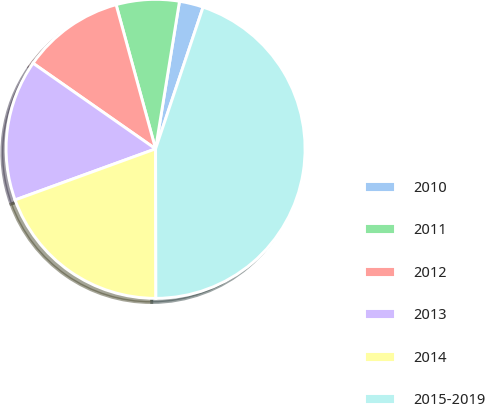Convert chart. <chart><loc_0><loc_0><loc_500><loc_500><pie_chart><fcel>2010<fcel>2011<fcel>2012<fcel>2013<fcel>2014<fcel>2015-2019<nl><fcel>2.59%<fcel>6.81%<fcel>11.04%<fcel>15.26%<fcel>19.48%<fcel>44.82%<nl></chart> 